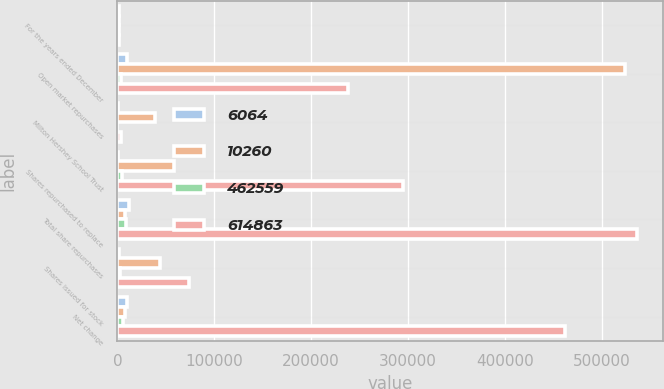Convert chart to OTSL. <chart><loc_0><loc_0><loc_500><loc_500><stacked_bar_chart><ecel><fcel>For the years ended December<fcel>Open market repurchases<fcel>Milton Hershey School Trust<fcel>Shares repurchased to replace<fcel>Total share repurchases<fcel>Shares issued for stock<fcel>Net change<nl><fcel>6064<fcel>2006<fcel>9912<fcel>689<fcel>1096<fcel>11697<fcel>1437<fcel>10260<nl><fcel>10260<fcel>2006<fcel>524387<fcel>38482<fcel>58779<fcel>7538.5<fcel>44564<fcel>7538.5<nl><fcel>462559<fcel>2005<fcel>4085<fcel>69<fcel>4859<fcel>9013<fcel>2949<fcel>6064<nl><fcel>614863<fcel>2005<fcel>238157<fcel>3936<fcel>294904<fcel>536997<fcel>74438<fcel>462559<nl></chart> 